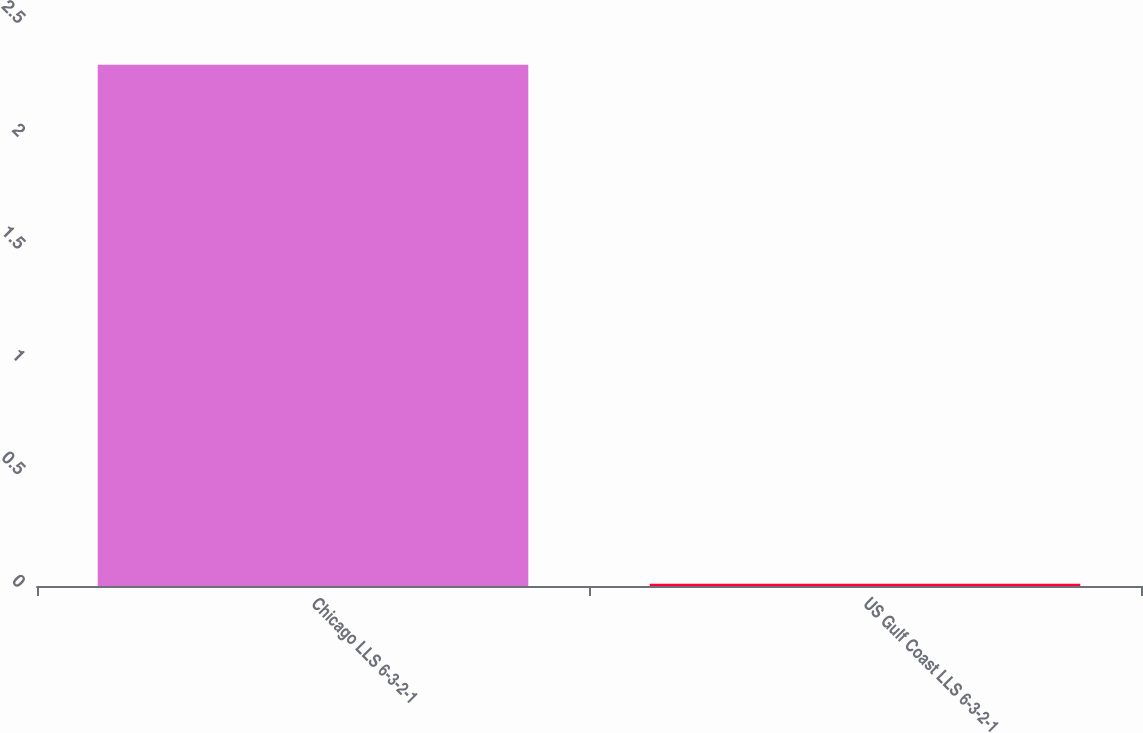Convert chart. <chart><loc_0><loc_0><loc_500><loc_500><bar_chart><fcel>Chicago LLS 6-3-2-1<fcel>US Gulf Coast LLS 6-3-2-1<nl><fcel>2.31<fcel>0.01<nl></chart> 